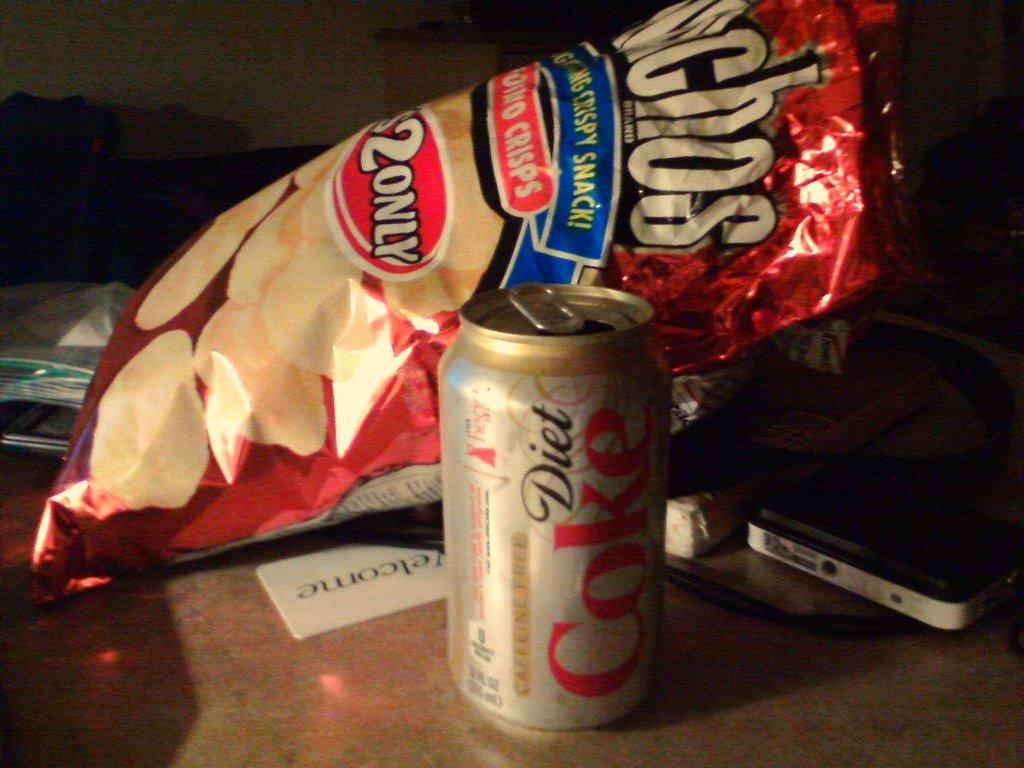<image>
Render a clear and concise summary of the photo. A diet coke and bag of munchos sit together on a table. 